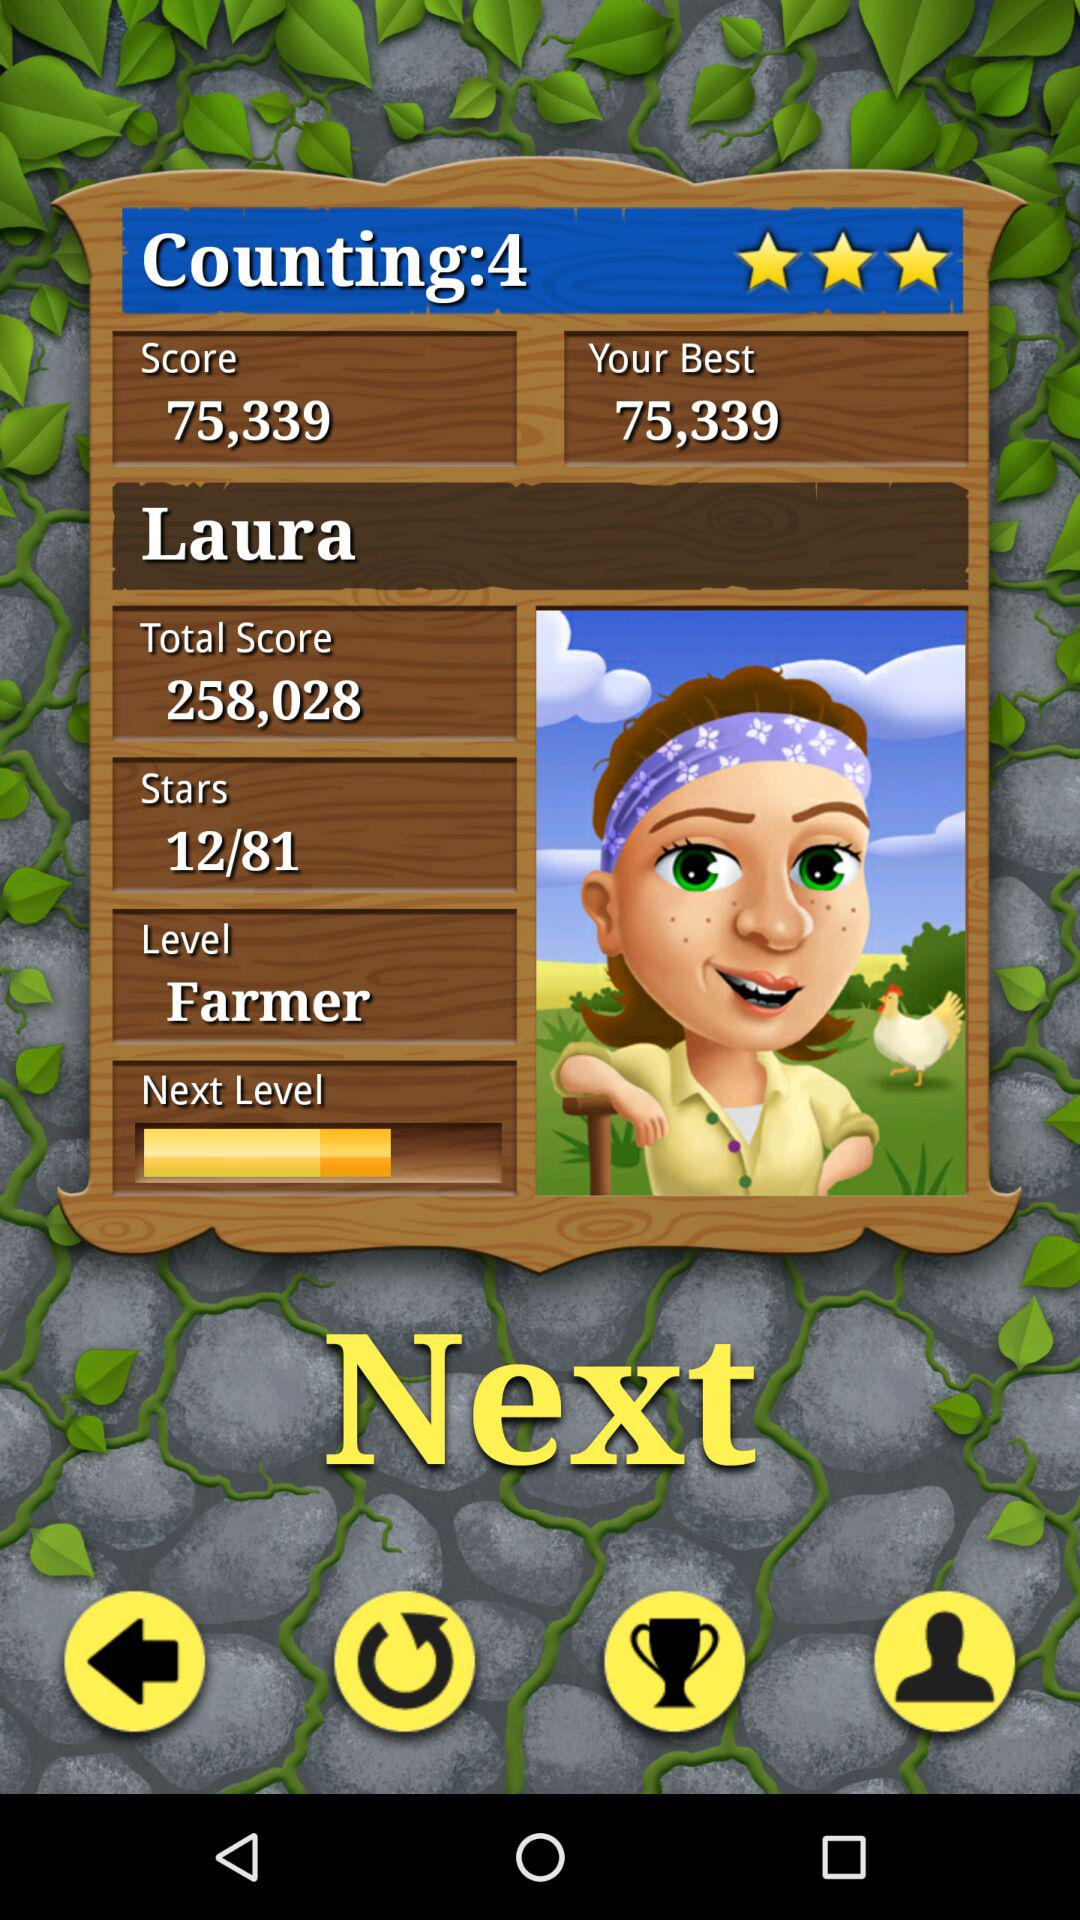What is the name? The name is Laura. 